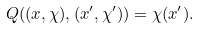Convert formula to latex. <formula><loc_0><loc_0><loc_500><loc_500>Q ( ( x , \chi ) , ( x ^ { \prime } , \chi ^ { \prime } ) ) = \chi ( x ^ { \prime } ) .</formula> 